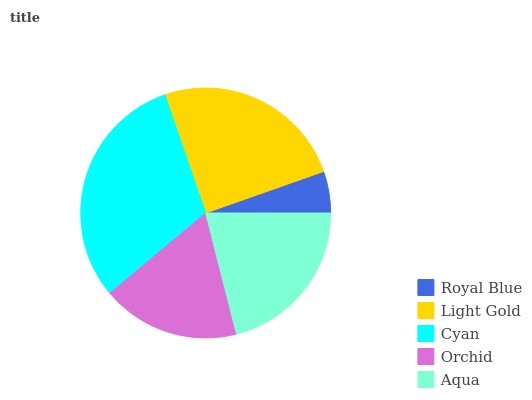Is Royal Blue the minimum?
Answer yes or no. Yes. Is Cyan the maximum?
Answer yes or no. Yes. Is Light Gold the minimum?
Answer yes or no. No. Is Light Gold the maximum?
Answer yes or no. No. Is Light Gold greater than Royal Blue?
Answer yes or no. Yes. Is Royal Blue less than Light Gold?
Answer yes or no. Yes. Is Royal Blue greater than Light Gold?
Answer yes or no. No. Is Light Gold less than Royal Blue?
Answer yes or no. No. Is Aqua the high median?
Answer yes or no. Yes. Is Aqua the low median?
Answer yes or no. Yes. Is Cyan the high median?
Answer yes or no. No. Is Orchid the low median?
Answer yes or no. No. 